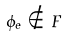Convert formula to latex. <formula><loc_0><loc_0><loc_500><loc_500>\phi _ { e } \notin F</formula> 